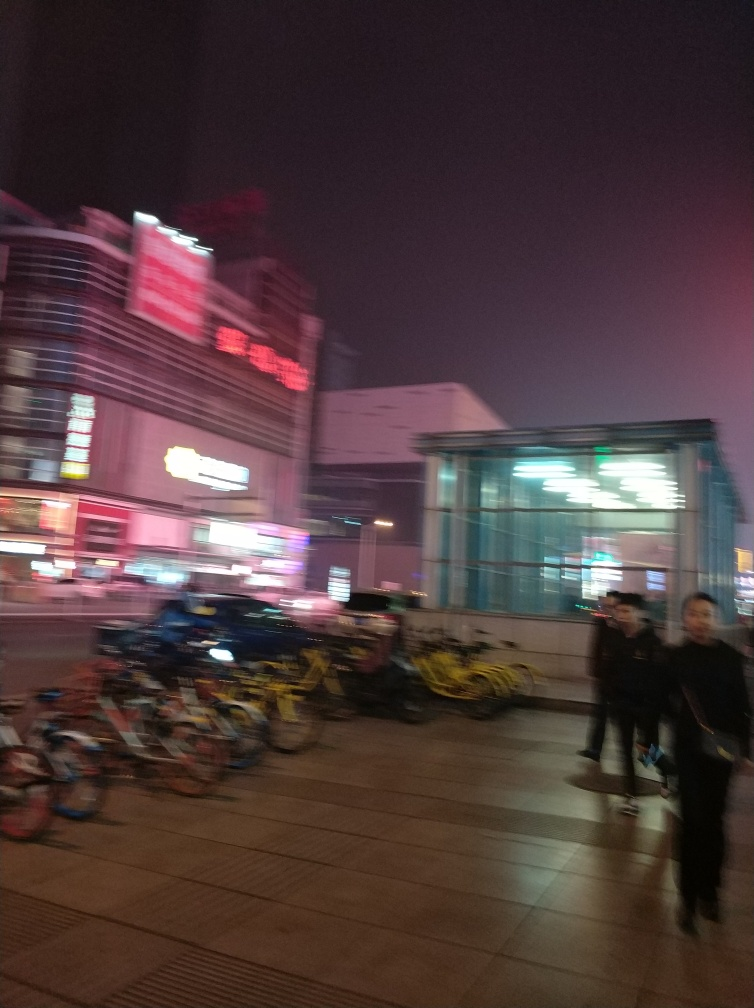Can you describe the atmosphere of the place shown in the image? Despite the blurriness, the image portrays a bustling urban environment with lit-up signage, indicating commercial activity. There are bicycles in disarray, suggesting it is a common area for transit and perhaps a touch of chaos. 